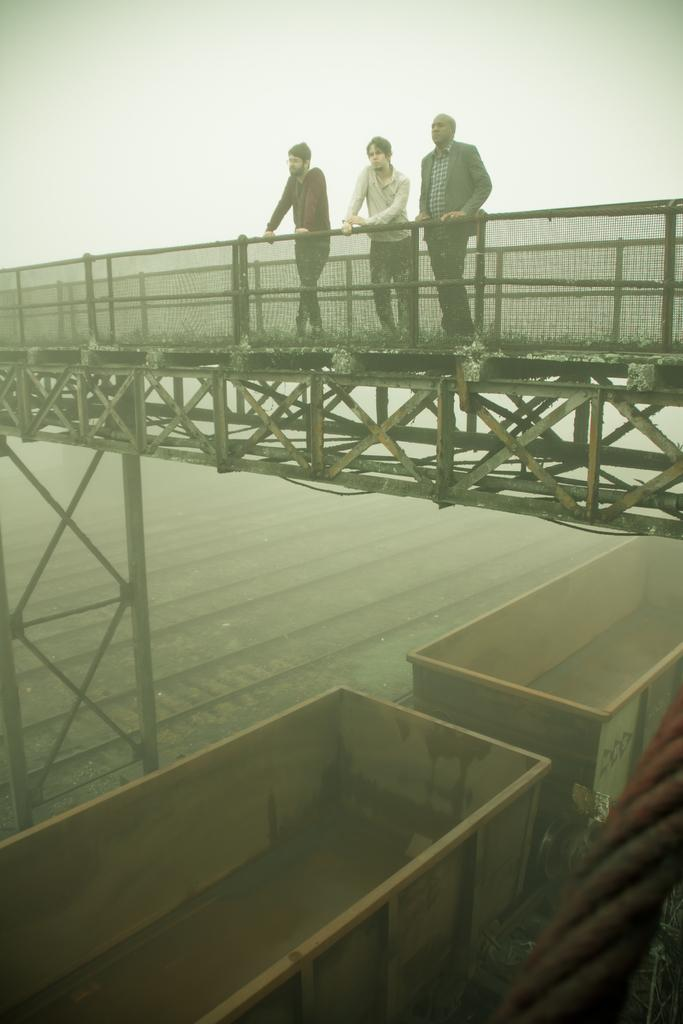How many people are on the bridge in the image? There are three persons standing on the bridge in the image. What can be seen on both sides of the bridge? There are boundaries on both sides of the bridge. What is visible on the ground in the image? There are tracks visible in the image. What is on the tracks in the image? There is a train on the tracks. How does the wind affect the train's movement in the image? There is no wind present in the image, so its effect on the train cannot be determined. What attempt is being made by the persons on the bridge in the image? There is no indication of any attempt being made by the persons on the bridge in the image. --- Facts: 1. There is a person holding a book in the image. 2. The person is sitting on a chair. 3. There is a table in front of the person. 4. The book has a yellow cover. Absurd Topics: dance, ocean, bird Conversation: What is the person in the image holding? The person in the image is holding a book. What is the person's position in the image? The person is sitting on a chair. What is in front of the person in the image? There is a table in front of the person. What color is the book's cover? The book has a yellow cover. Reasoning: Let's think step by step in order to produce the conversation. We start by identifying the main subject in the image, which is the person holding a book. Then, we expand the conversation to include the person's position and the presence of a table. Finally, we mention the color of the book's cover, which is a specific detail about the book. Each question is designed to elicit a specific detail about the image that is known from the provided facts. Absurd Question/Answer: Can you see any birds flying over the ocean in the image? There is no ocean or birds present in the image; it features a person sitting on a chair holding a book with a yellow cover. 